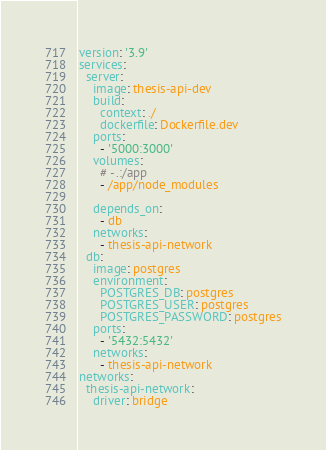<code> <loc_0><loc_0><loc_500><loc_500><_YAML_>version: '3.9'
services:
  server:
    image: thesis-api-dev
    build:
      context: ./
      dockerfile: Dockerfile.dev
    ports:
      - '5000:3000'
    volumes:
      # - .:/app
      - /app/node_modules

    depends_on:
      - db
    networks:
      - thesis-api-network
  db:
    image: postgres
    environment:
      POSTGRES_DB: postgres
      POSTGRES_USER: postgres
      POSTGRES_PASSWORD: postgres
    ports:
      - '5432:5432'
    networks:
      - thesis-api-network
networks:
  thesis-api-network:
    driver: bridge
</code> 